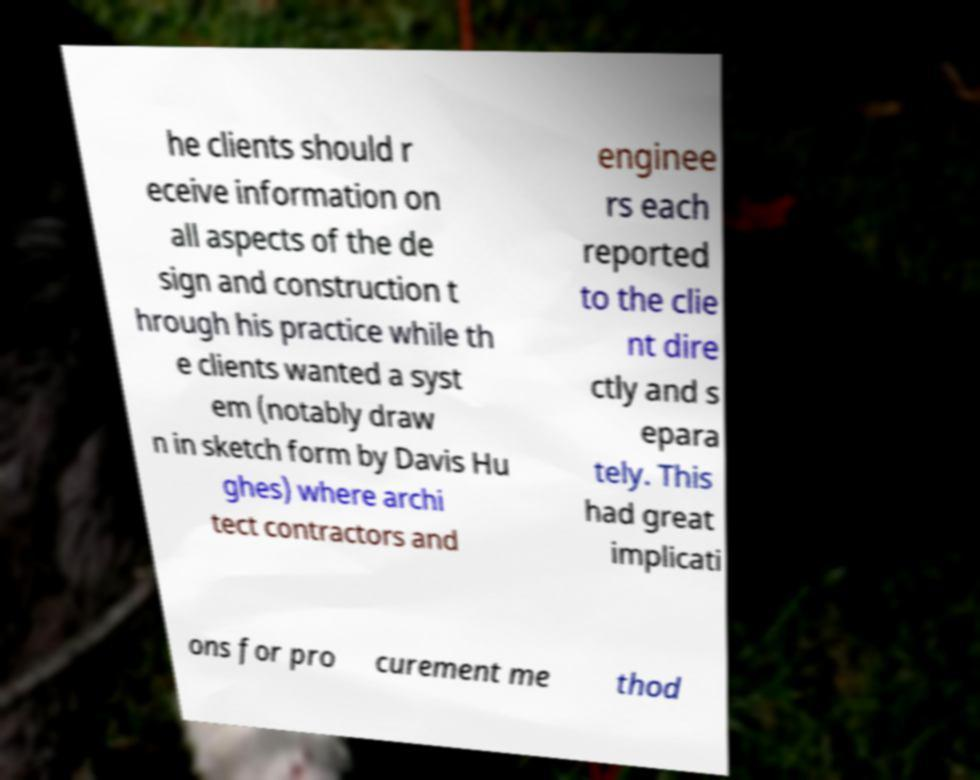Could you extract and type out the text from this image? he clients should r eceive information on all aspects of the de sign and construction t hrough his practice while th e clients wanted a syst em (notably draw n in sketch form by Davis Hu ghes) where archi tect contractors and enginee rs each reported to the clie nt dire ctly and s epara tely. This had great implicati ons for pro curement me thod 